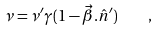Convert formula to latex. <formula><loc_0><loc_0><loc_500><loc_500>\nu = \nu ^ { \prime } \gamma ( 1 - \vec { \beta } . \hat { n } ^ { \prime } ) \quad ,</formula> 